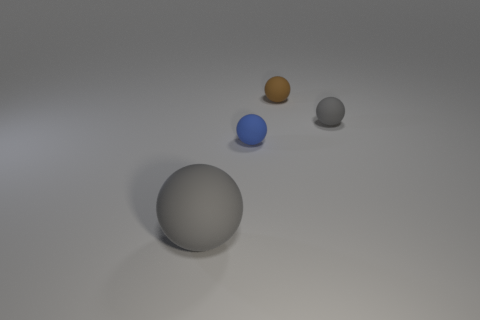Subtract all tiny gray balls. How many balls are left? 3 Subtract all blue balls. How many balls are left? 3 Add 4 yellow blocks. How many objects exist? 8 Subtract 2 balls. How many balls are left? 2 Subtract all red cubes. How many gray balls are left? 2 Subtract all gray spheres. Subtract all brown cylinders. How many spheres are left? 2 Subtract all small yellow cylinders. Subtract all tiny blue things. How many objects are left? 3 Add 1 matte spheres. How many matte spheres are left? 5 Add 2 big gray spheres. How many big gray spheres exist? 3 Subtract 0 red cylinders. How many objects are left? 4 